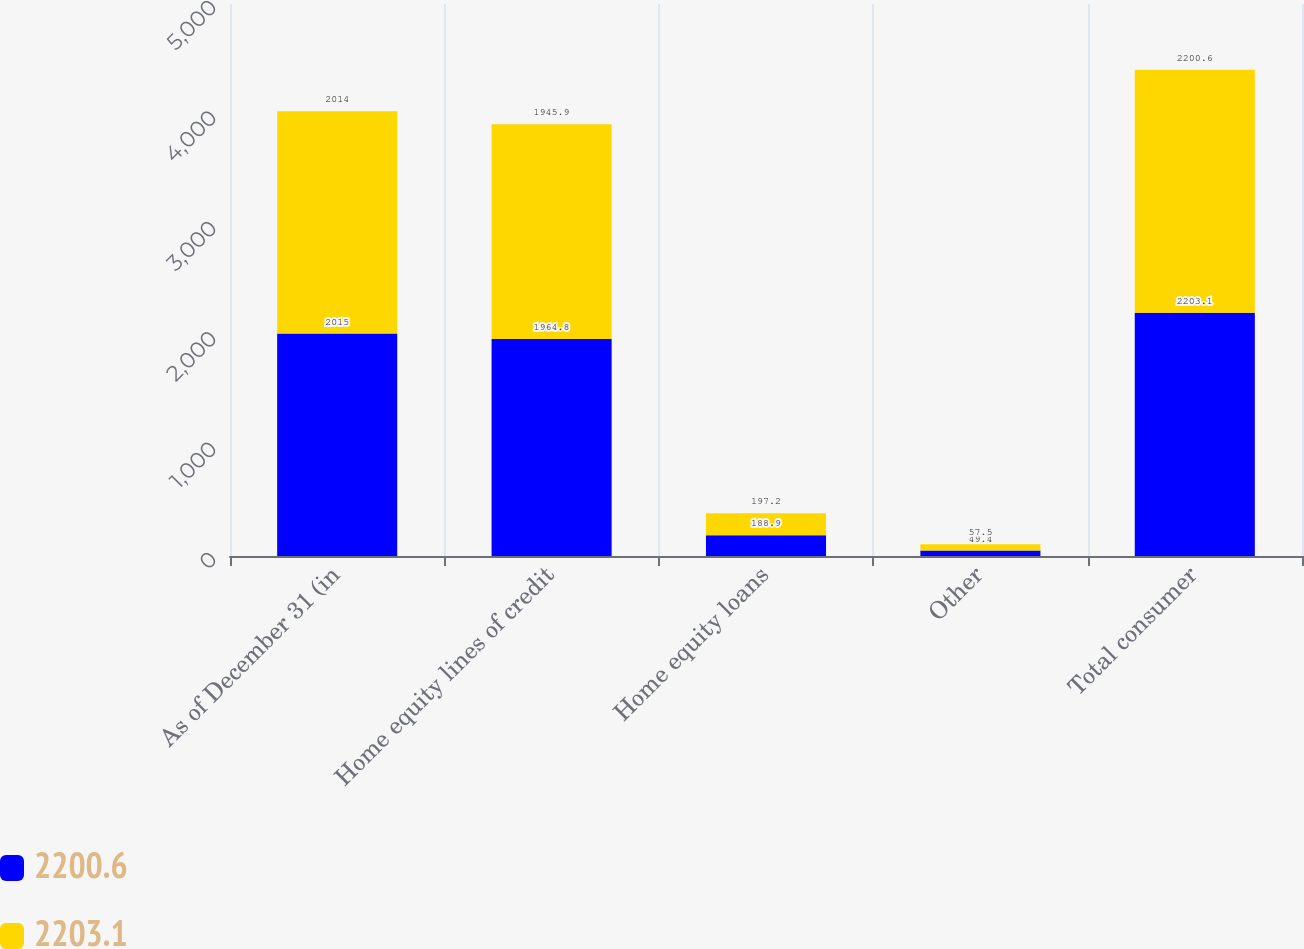Convert chart. <chart><loc_0><loc_0><loc_500><loc_500><stacked_bar_chart><ecel><fcel>As of December 31 (in<fcel>Home equity lines of credit<fcel>Home equity loans<fcel>Other<fcel>Total consumer<nl><fcel>2200.6<fcel>2015<fcel>1964.8<fcel>188.9<fcel>49.4<fcel>2203.1<nl><fcel>2203.1<fcel>2014<fcel>1945.9<fcel>197.2<fcel>57.5<fcel>2200.6<nl></chart> 